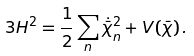Convert formula to latex. <formula><loc_0><loc_0><loc_500><loc_500>3 H ^ { 2 } = \frac { 1 } { 2 } \sum _ { n } \dot { \bar { \chi } } _ { n } ^ { 2 } + V ( \bar { \chi } ) \, .</formula> 